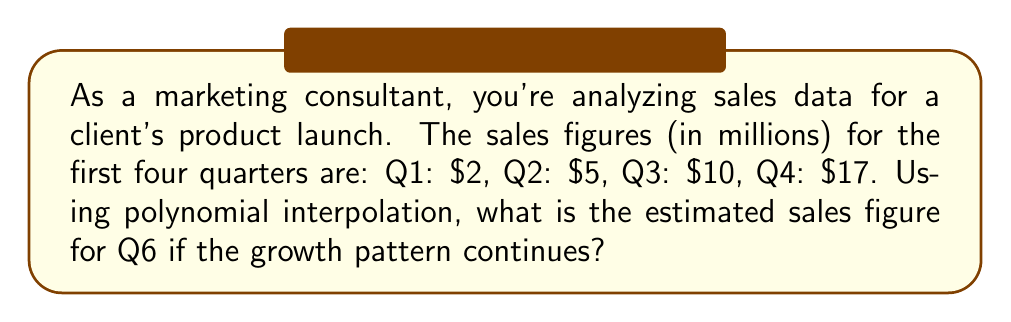Give your solution to this math problem. To solve this problem, we'll use Lagrange polynomial interpolation:

1) First, we'll set up our data points:
   $(1,2), (2,5), (3,10), (4,17)$

2) The Lagrange interpolation polynomial is:
   $$P(x) = \sum_{i=1}^n y_i \cdot L_i(x)$$
   where $L_i(x) = \prod_{j=1, j\neq i}^n \frac{x-x_j}{x_i-x_j}$

3) Calculating each $L_i(x)$:
   $$L_1(x) = \frac{(x-2)(x-3)(x-4)}{(1-2)(1-3)(1-4)} = -\frac{1}{6}(x-2)(x-3)(x-4)$$
   $$L_2(x) = \frac{(x-1)(x-3)(x-4)}{(2-1)(2-3)(2-4)} = \frac{1}{2}(x-1)(x-3)(x-4)$$
   $$L_3(x) = \frac{(x-1)(x-2)(x-4)}{(3-1)(3-2)(3-4)} = -\frac{1}{2}(x-1)(x-2)(x-4)$$
   $$L_4(x) = \frac{(x-1)(x-2)(x-3)}{(4-1)(4-2)(4-3)} = \frac{1}{6}(x-1)(x-2)(x-3)$$

4) Now, we can form our interpolation polynomial:
   $$P(x) = 2L_1(x) + 5L_2(x) + 10L_3(x) + 17L_4(x)$$

5) Simplifying:
   $$P(x) = \frac{1}{6}(-x^3 + 6x^2 - 11x + 6)$$

6) To estimate Q6 sales, we evaluate $P(6)$:
   $$P(6) = \frac{1}{6}(-216 + 216 - 66 + 6) = -10$$

7) Therefore, the estimated sales for Q6 is $26 million.
Answer: $26 million 